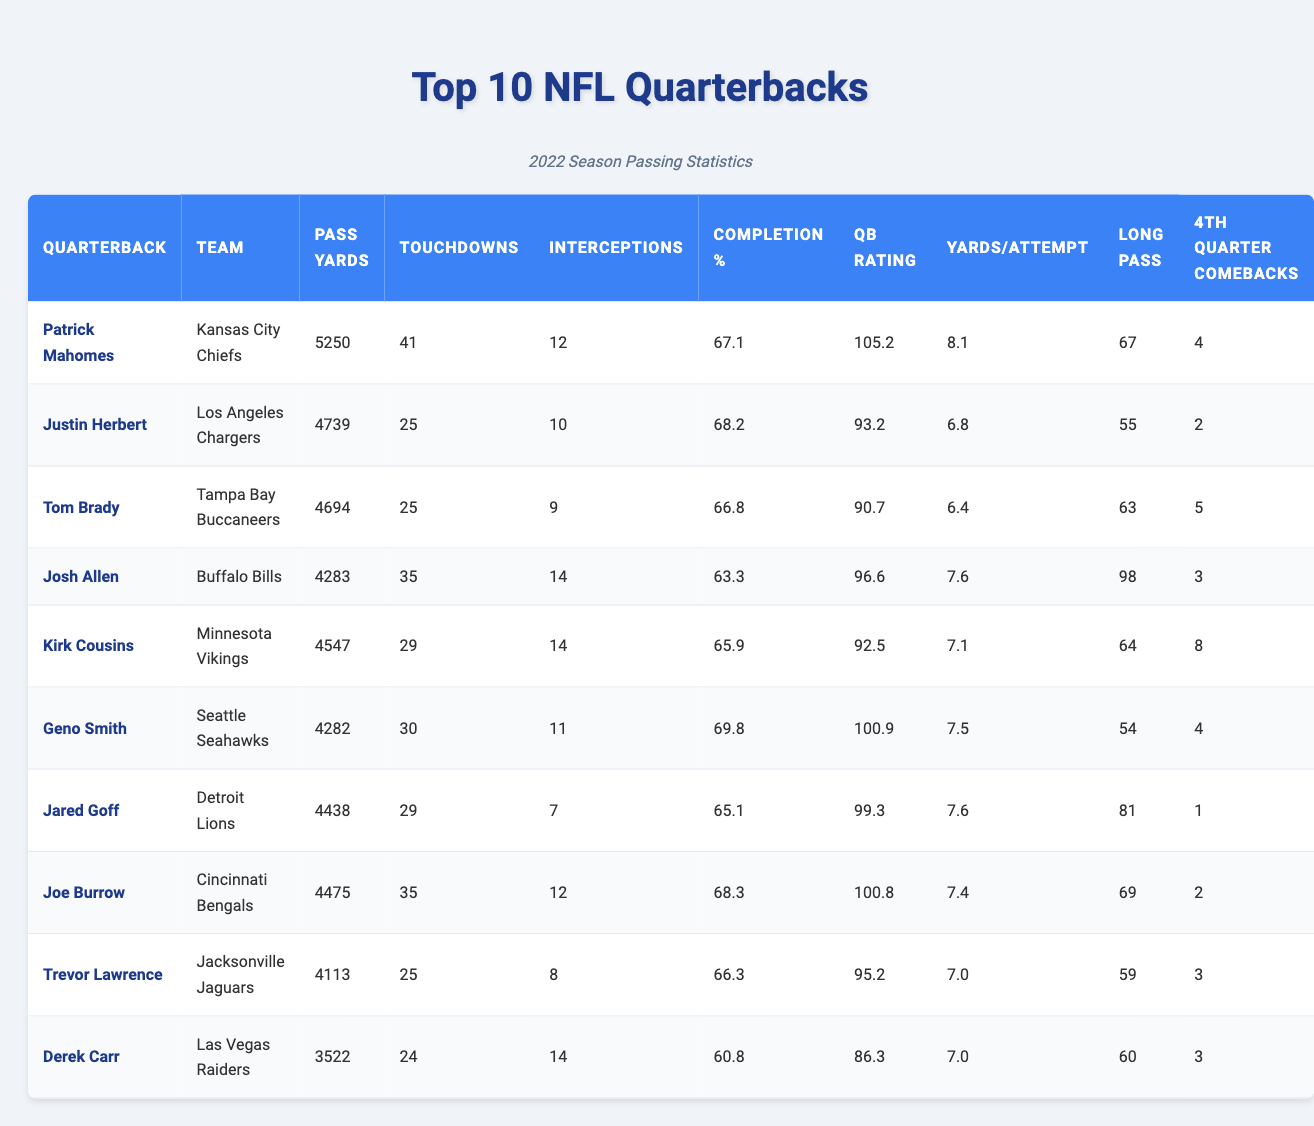What quarterback had the most passing yards in the 2022 season? From the table, Patrick Mahomes has the highest passing yards listed at 5250.
Answer: Patrick Mahomes Which quarterback had the lowest completion percentage? The table shows that Derek Carr has the lowest completion percentage at 60.8%.
Answer: Derek Carr How many touchdowns did Josh Allen throw? Referring to the table, Josh Allen is noted to have thrown 35 touchdowns.
Answer: 35 Which team did Tom Brady play for in the 2022 season? The table indicates Tom Brady played for the Tampa Bay Buccaneers.
Answer: Tampa Bay Buccaneers Who has more touchdowns: Joe Burrow or Geno Smith? By checking the touchdowns column, Joe Burrow has 35 touchdowns while Geno Smith has 30. Thus, Joe Burrow has more.
Answer: Joe Burrow What is the total number of interceptions thrown by all quarterbacks in the table? Adding up the interceptions: 12 + 10 + 9 + 14 + 14 + 11 + 7 + 12 + 8 + 14 = 117.
Answer: 117 Which quarterback had the most fourth-quarter comebacks? Looking at the fourth-quarter comebacks column, Kirk Cousins has 8 comebacks, which is the highest.
Answer: Kirk Cousins On average, how many yards per attempt did the top 10 quarterbacks achieve? To find the average of yards per attempt, sum the values (8.1 + 6.8 + 6.4 + 7.6 + 7.1 + 7.5 + 7.6 + 7.4 + 7.0 + 7.0) = 75.2, then divide by 10 to get 7.52.
Answer: 7.52 Is it true that all quarterbacks listed had a QB rating above 90? By checking the QB Rating column, Derek Carr has a rating of 86.3, which is below 90, so the statement is false.
Answer: False Which quarterback had the longest pass, and what was the yardage? The longest pass yardage is listed under "Long Pass" for Josh Allen at 98 yards.
Answer: Josh Allen, 98 yards 